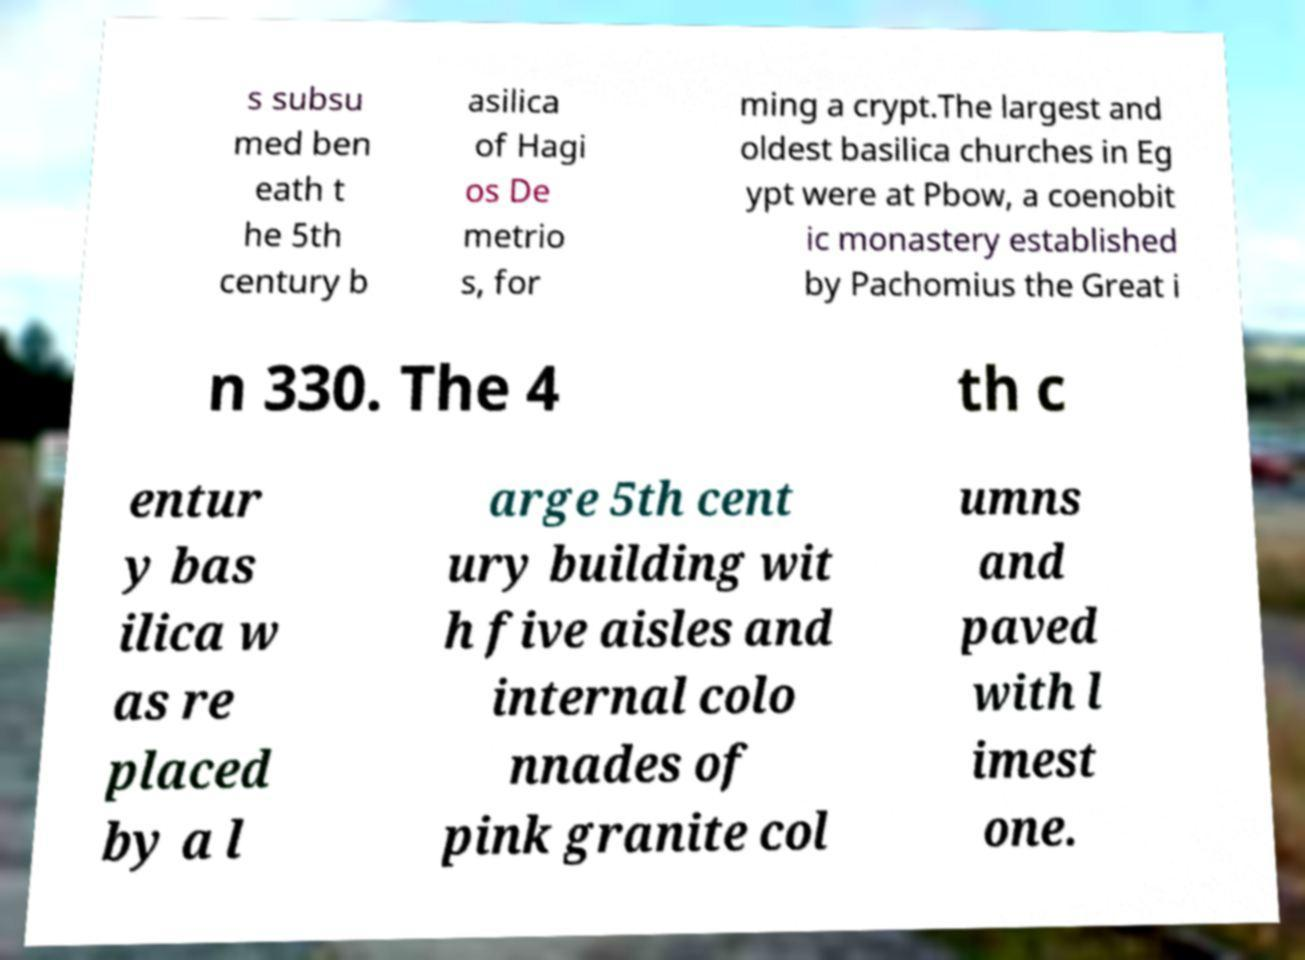Can you read and provide the text displayed in the image?This photo seems to have some interesting text. Can you extract and type it out for me? s subsu med ben eath t he 5th century b asilica of Hagi os De metrio s, for ming a crypt.The largest and oldest basilica churches in Eg ypt were at Pbow, a coenobit ic monastery established by Pachomius the Great i n 330. The 4 th c entur y bas ilica w as re placed by a l arge 5th cent ury building wit h five aisles and internal colo nnades of pink granite col umns and paved with l imest one. 